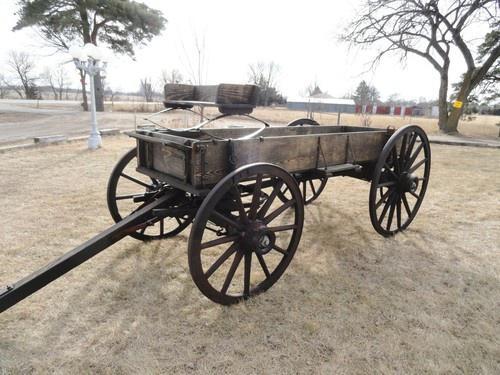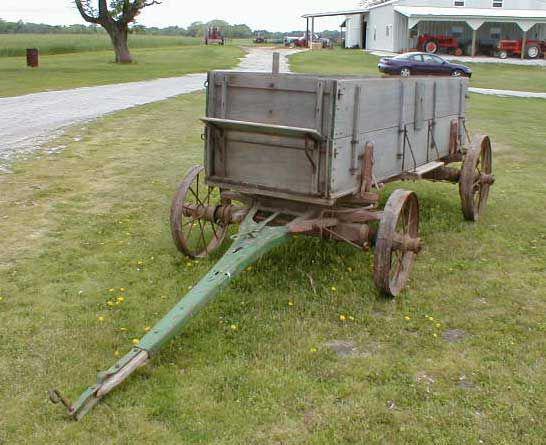The first image is the image on the left, the second image is the image on the right. Given the left and right images, does the statement "The wagon in the image on the right is not attached to a horse." hold true? Answer yes or no. Yes. The first image is the image on the left, the second image is the image on the right. Considering the images on both sides, is "An image shows two side-by-side horses pulling some type of wheeled thing steered by a man." valid? Answer yes or no. No. 